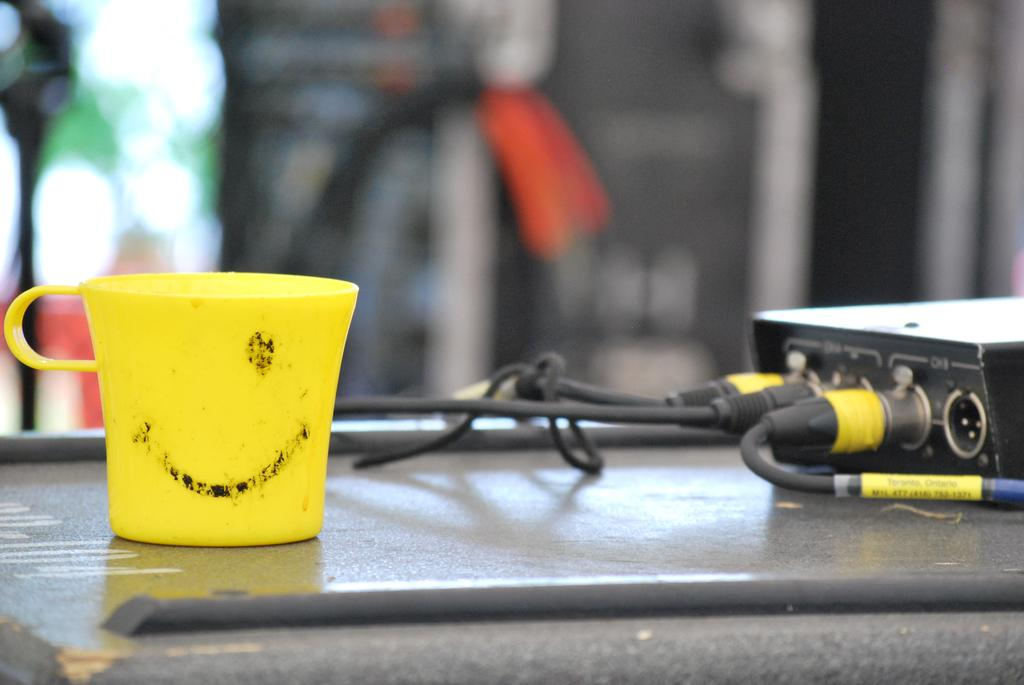What object is present in the image that can hold liquids? There is a cup in the image. What color is the cup? The cup is yellow. Where is the cup located in the image? The cup is on a surface. What other objects can be seen in the image? There are wires in the image. What color are the wires? The wires are black. How would you describe the background of the image? The background of the image is blurred. Can you describe the pain experienced by the cup in the image? There is no pain experienced by the cup in the image, as it is an inanimate object. 